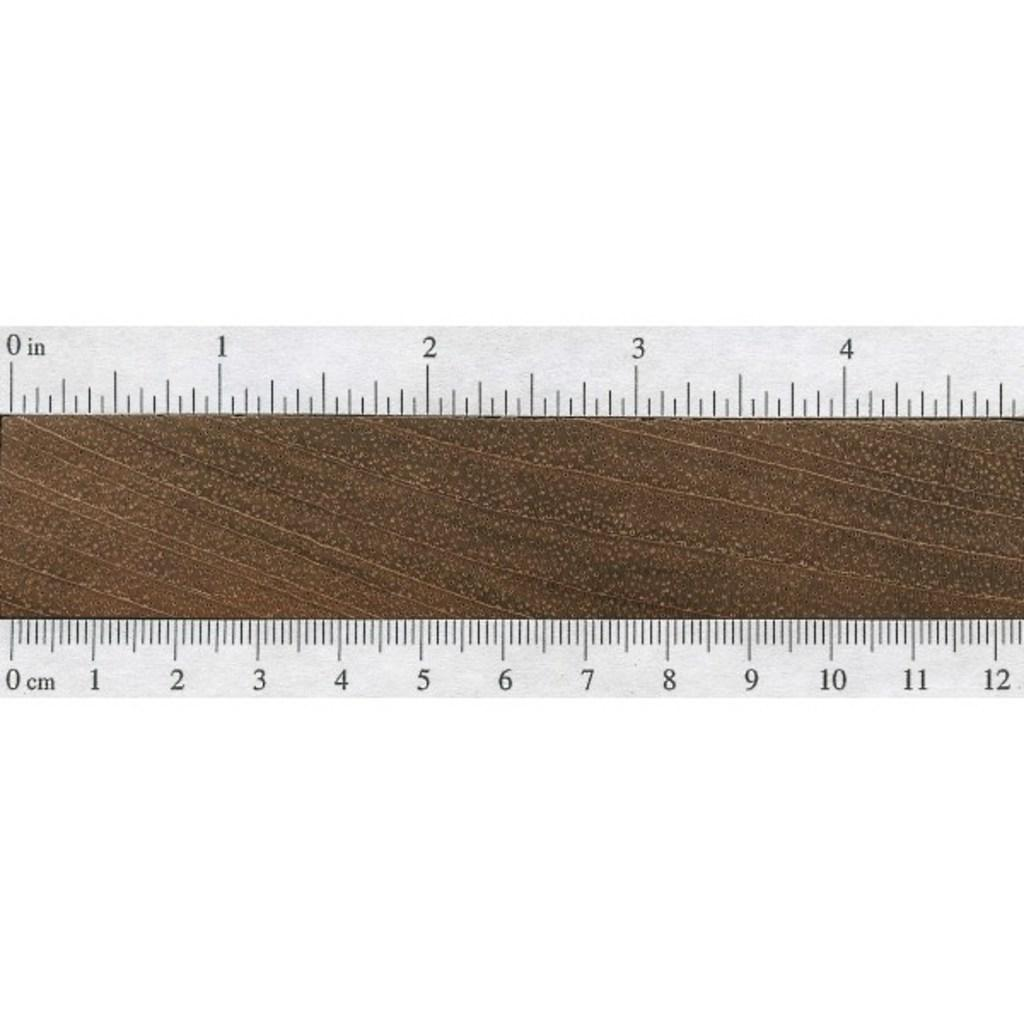<image>
Create a compact narrative representing the image presented. A ruler  measures 12 centimeters or around 5 inches of a brown material. 